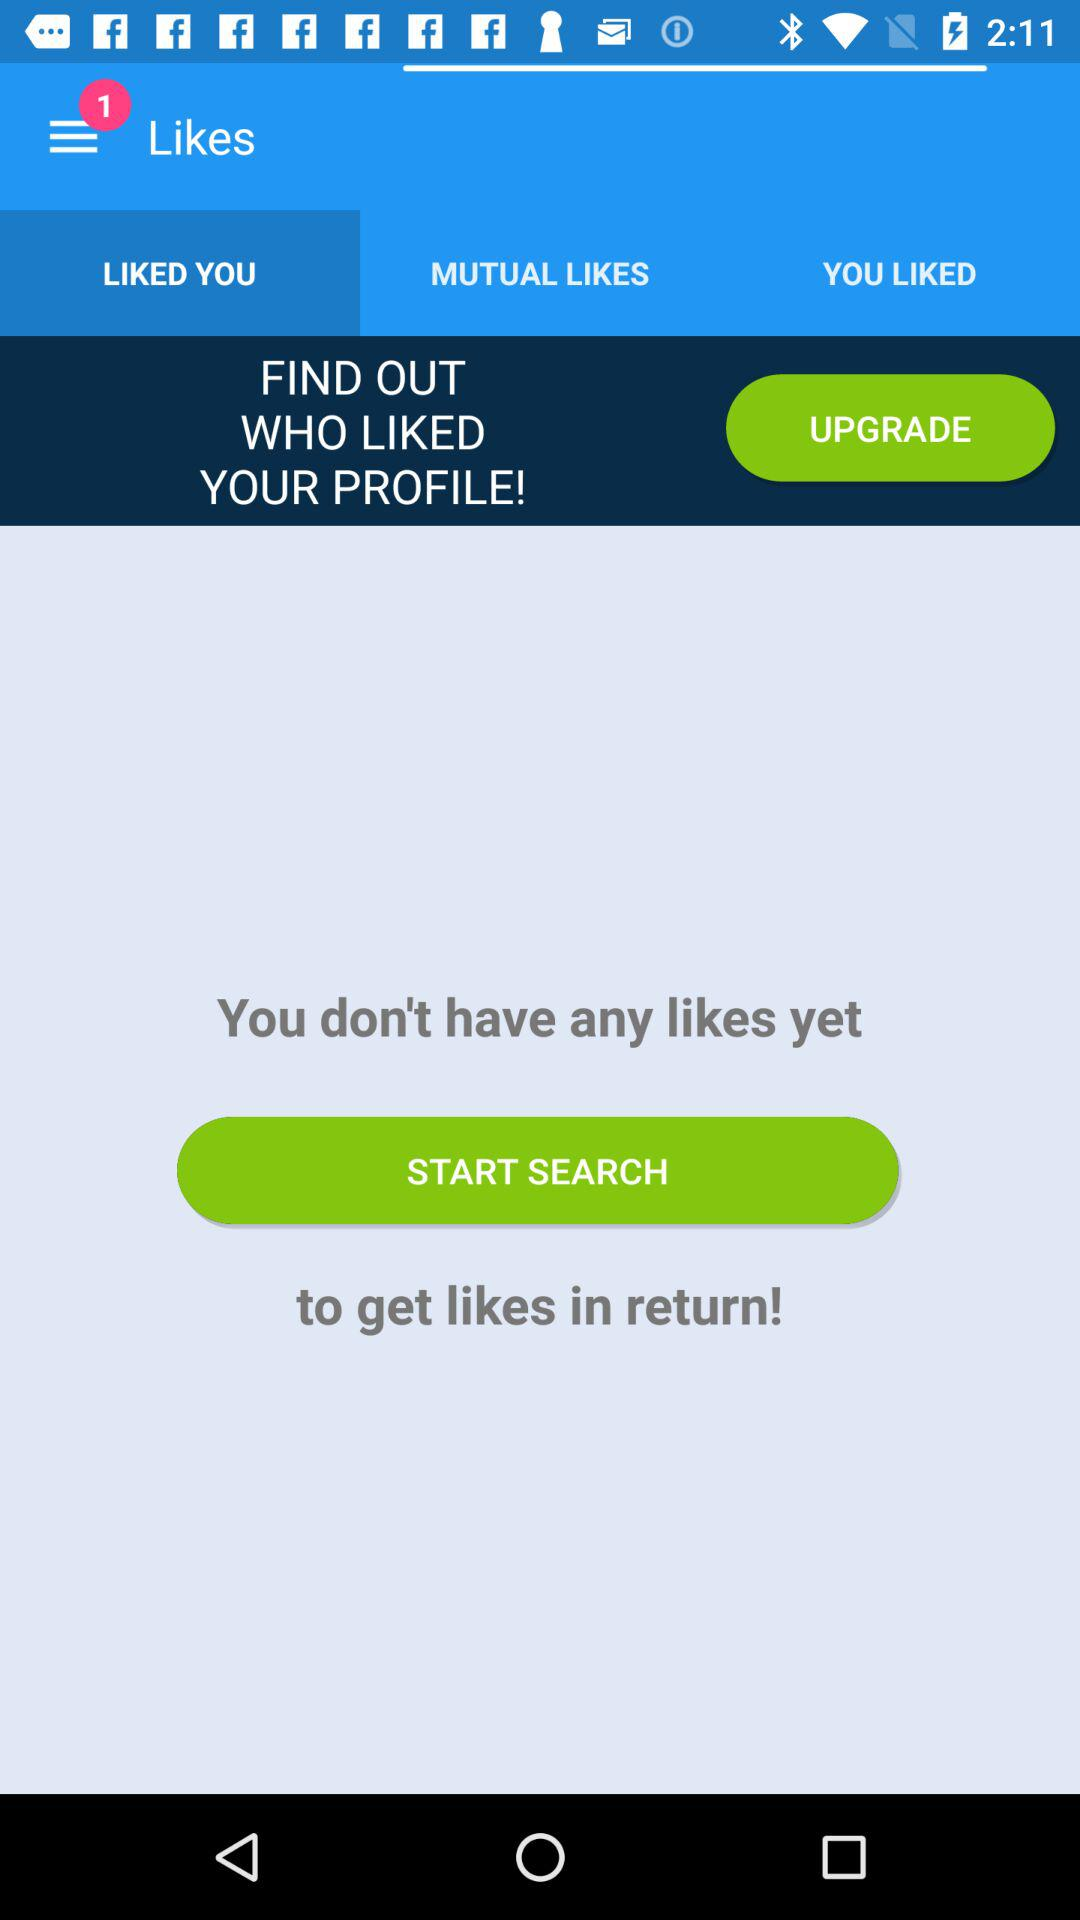Which tab is selected? The selected tab is "LIKED YOU". 